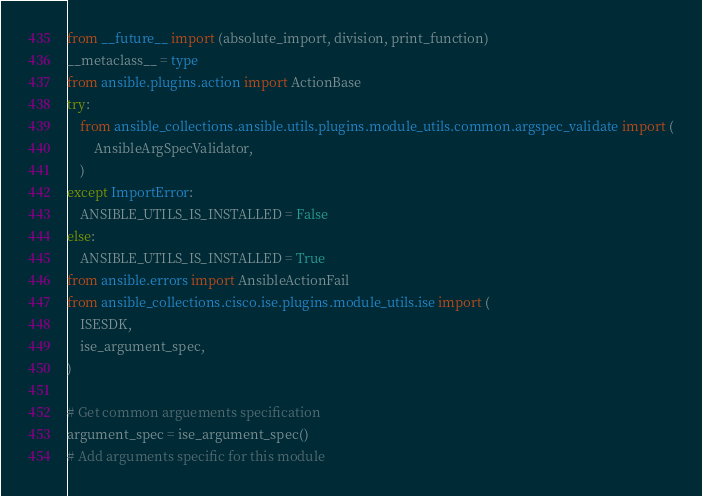<code> <loc_0><loc_0><loc_500><loc_500><_Python_>from __future__ import (absolute_import, division, print_function)
__metaclass__ = type
from ansible.plugins.action import ActionBase
try:
    from ansible_collections.ansible.utils.plugins.module_utils.common.argspec_validate import (
        AnsibleArgSpecValidator,
    )
except ImportError:
    ANSIBLE_UTILS_IS_INSTALLED = False
else:
    ANSIBLE_UTILS_IS_INSTALLED = True
from ansible.errors import AnsibleActionFail
from ansible_collections.cisco.ise.plugins.module_utils.ise import (
    ISESDK,
    ise_argument_spec,
)

# Get common arguements specification
argument_spec = ise_argument_spec()
# Add arguments specific for this module</code> 